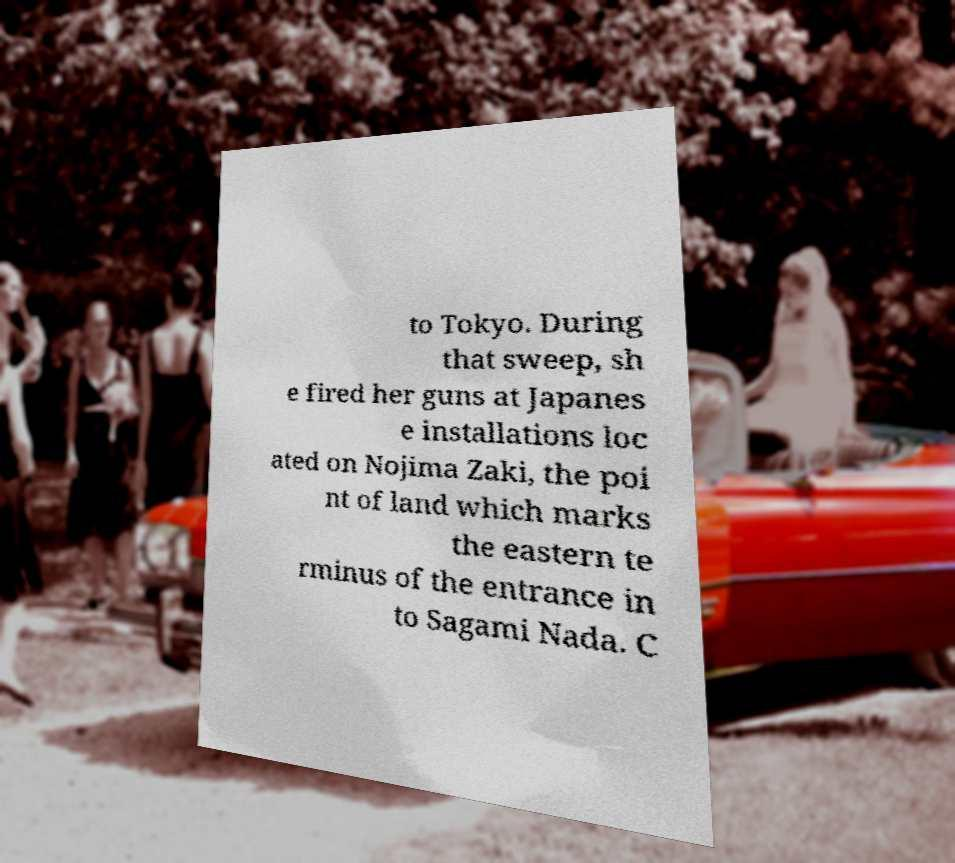Could you extract and type out the text from this image? to Tokyo. During that sweep, sh e fired her guns at Japanes e installations loc ated on Nojima Zaki, the poi nt of land which marks the eastern te rminus of the entrance in to Sagami Nada. C 